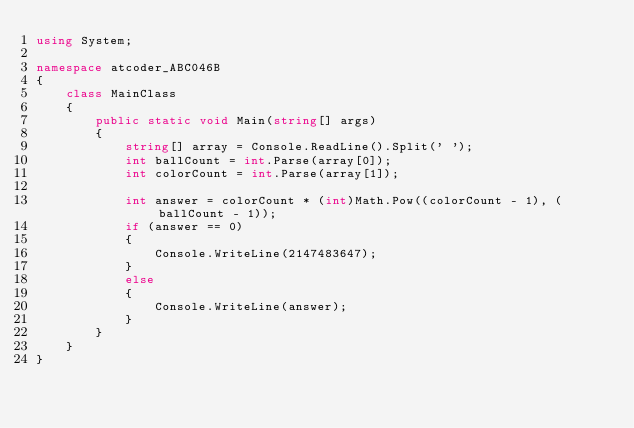Convert code to text. <code><loc_0><loc_0><loc_500><loc_500><_C#_>using System;

namespace atcoder_ABC046B
{
    class MainClass
    {
        public static void Main(string[] args)
        {
			string[] array = Console.ReadLine().Split(' ');
			int ballCount = int.Parse(array[0]);
			int colorCount = int.Parse(array[1]);

			int answer = colorCount * (int)Math.Pow((colorCount - 1), (ballCount - 1));
			if (answer == 0)
			{
				Console.WriteLine(2147483647);
			}
			else
			{
				Console.WriteLine(answer);
			}
		}
    }
}</code> 